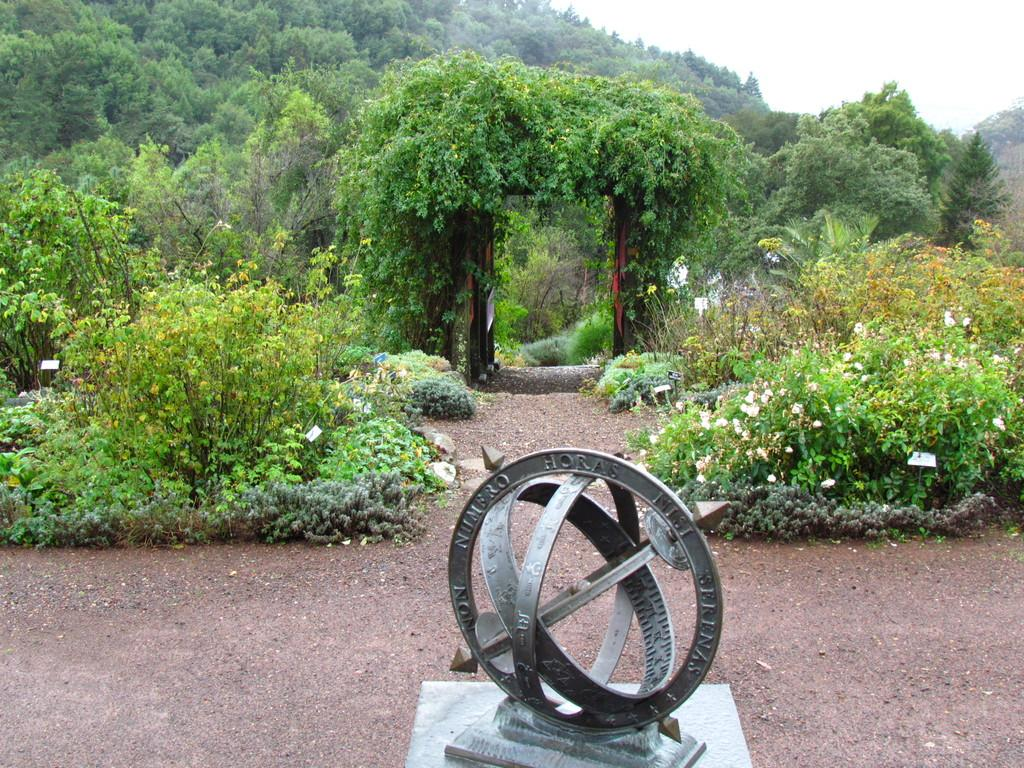What type of object is on the platform in the image? There is a metal object on a platform in the image. What can be seen in the background of the image? There are plants with flowers, doors, trees, and the sky visible in the background of the image. What type of muscle is being flexed by the person in the image? There is no person present in the image, so it is not possible to determine if any muscles are being flexed. 